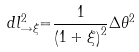<formula> <loc_0><loc_0><loc_500><loc_500>d l _ { \rightarrow \xi } ^ { 2 } { = } \frac { 1 } { \left ( 1 + \xi \right ) ^ { 2 } } \Delta \theta ^ { 2 }</formula> 